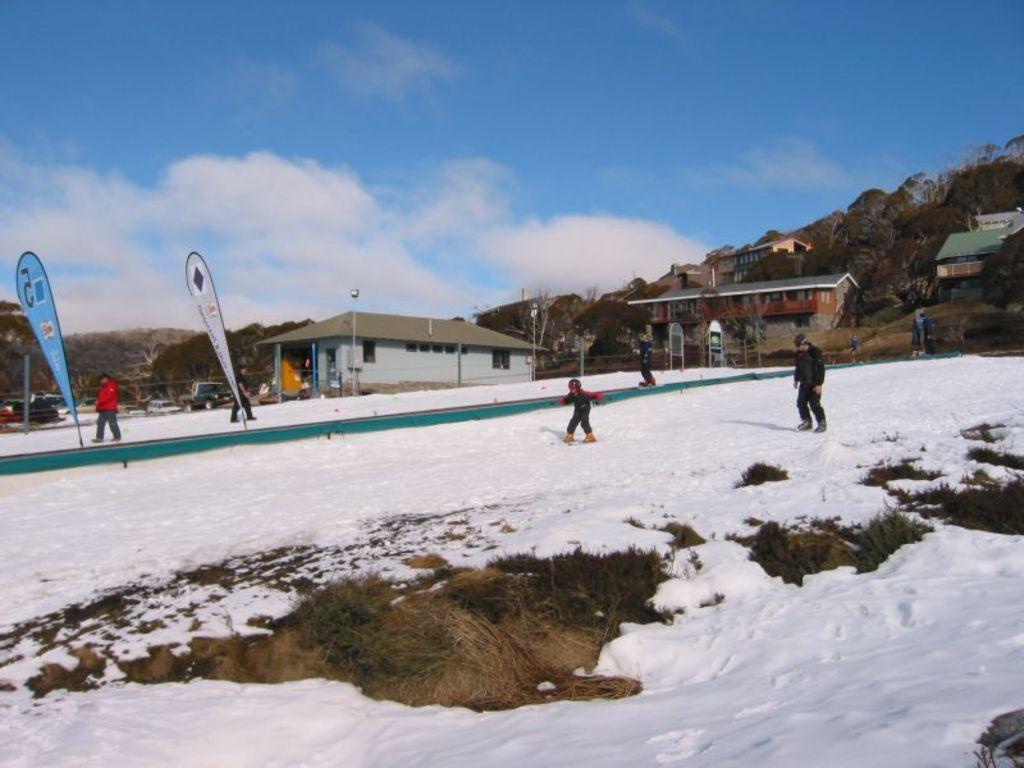Please provide a concise description of this image. In this image, we can see persons wearing clothes and skating on the snow. There are persons in the middle of the image. There are clouds in the sky. 